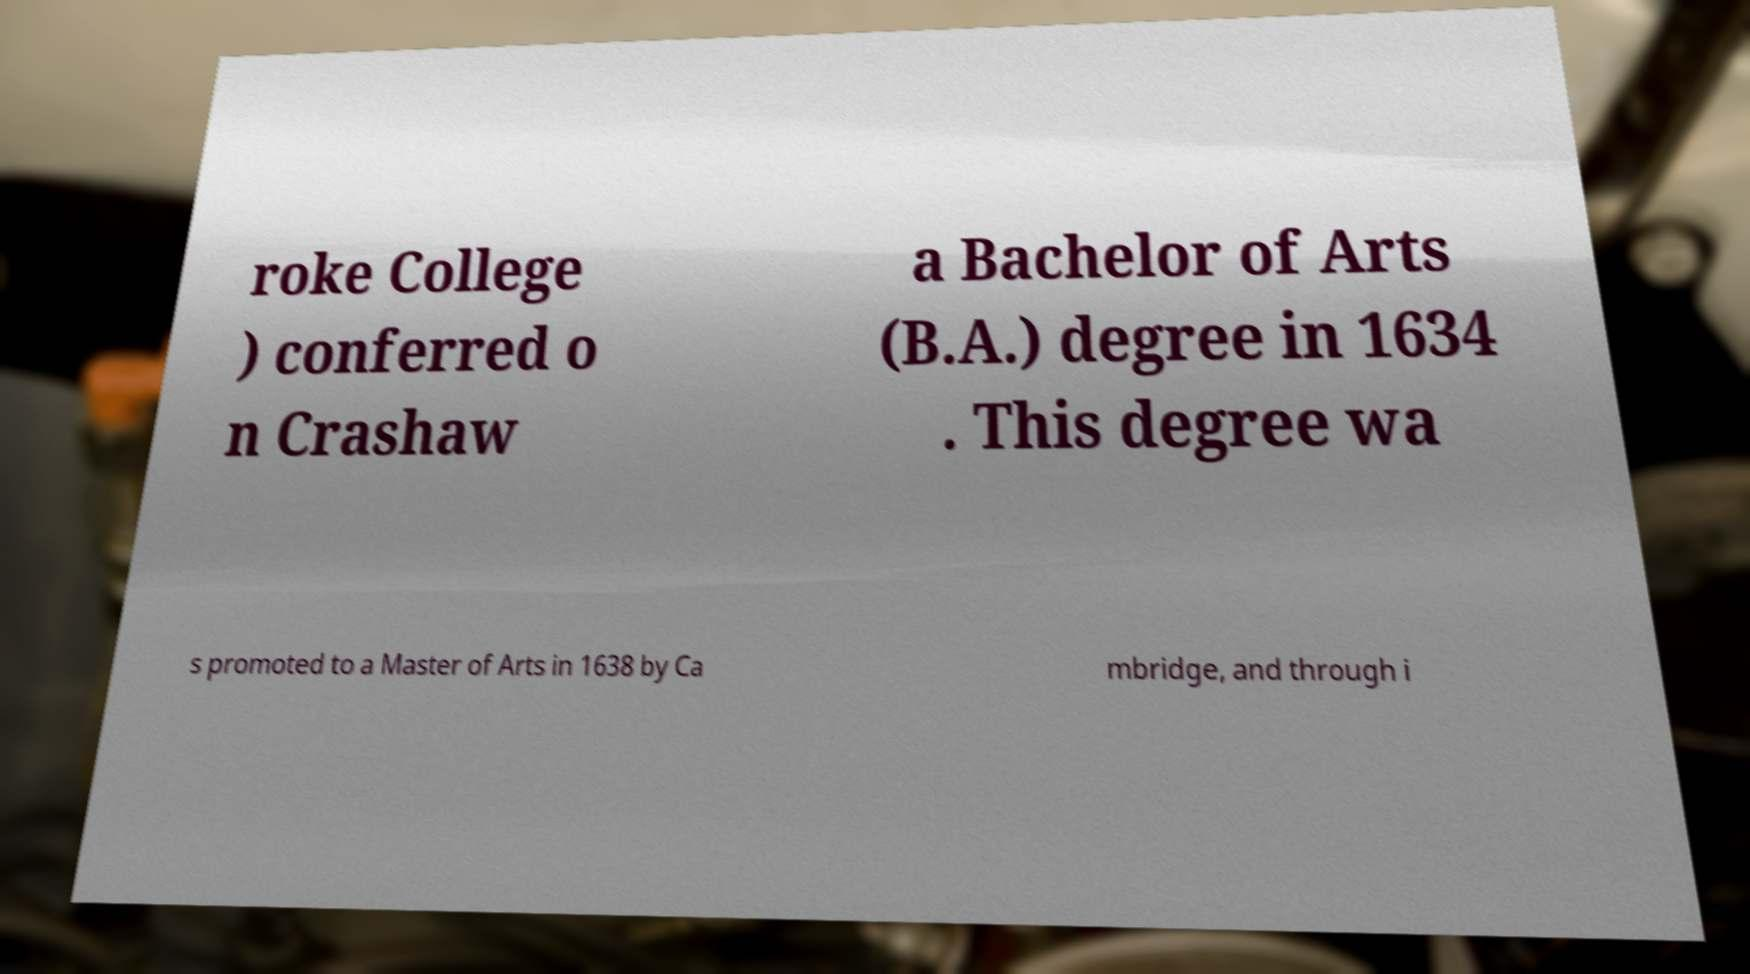Can you read and provide the text displayed in the image?This photo seems to have some interesting text. Can you extract and type it out for me? roke College ) conferred o n Crashaw a Bachelor of Arts (B.A.) degree in 1634 . This degree wa s promoted to a Master of Arts in 1638 by Ca mbridge, and through i 